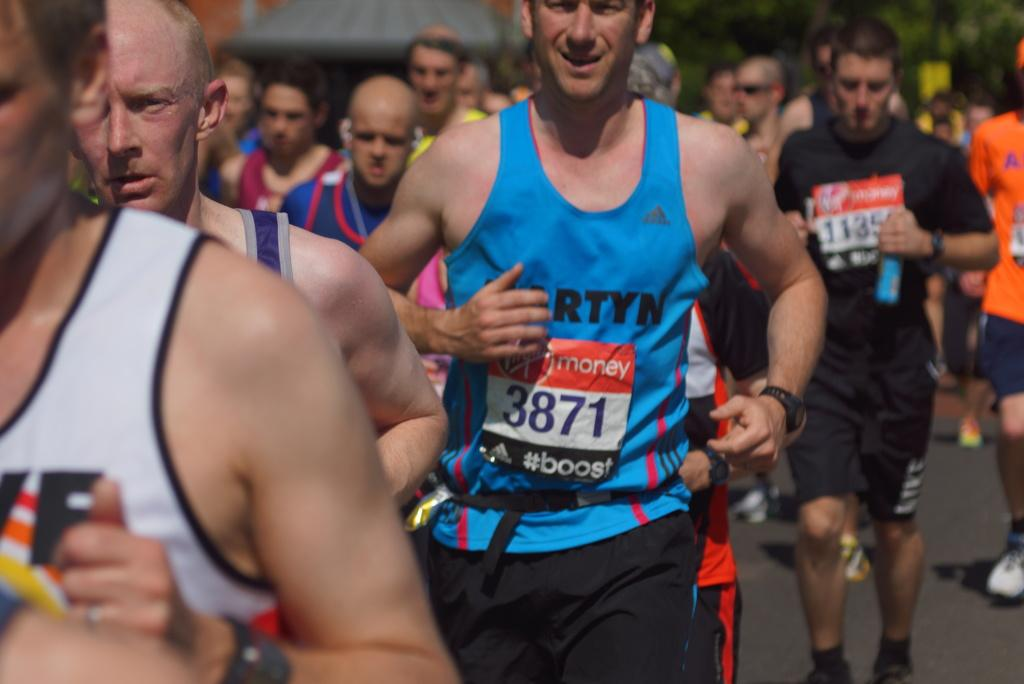How many people are in the image? There are persons in the image, but the exact number is not specified. What are the persons wearing in the image? The persons are wearing clothes in the image. What type of skirt can be seen on the snake in the image? There are no snakes or skirts present in the image. What causes the persons to laugh in the image? The image does not depict any laughter or indicate a reason for laughter. 